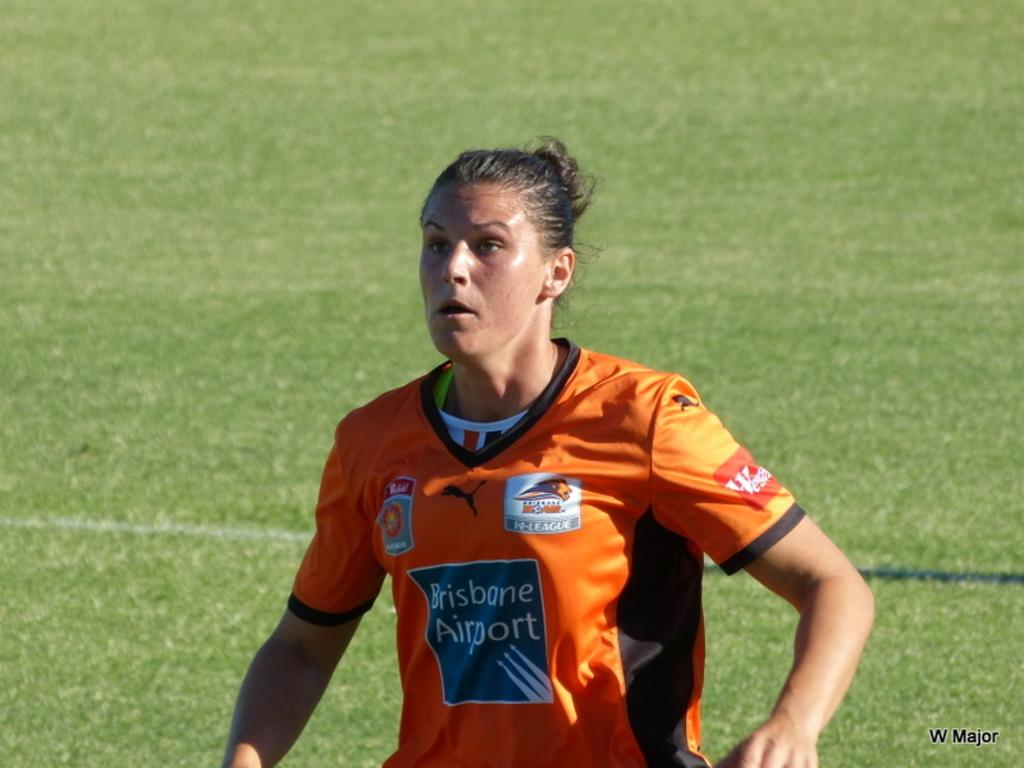<image>
Offer a succinct explanation of the picture presented. A woman is on a sports field with a jersey reading Brisbane Airport. 